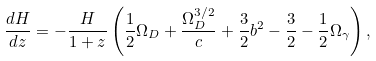<formula> <loc_0><loc_0><loc_500><loc_500>\frac { d H } { d z } = - \frac { H } { 1 + z } \left ( \frac { 1 } { 2 } \Omega _ { D } + \frac { \Omega ^ { 3 / 2 } _ { D } } { c } + \frac { 3 } { 2 } b ^ { 2 } - \frac { 3 } { 2 } - \frac { 1 } { 2 } \Omega _ { \gamma } \right ) ,</formula> 